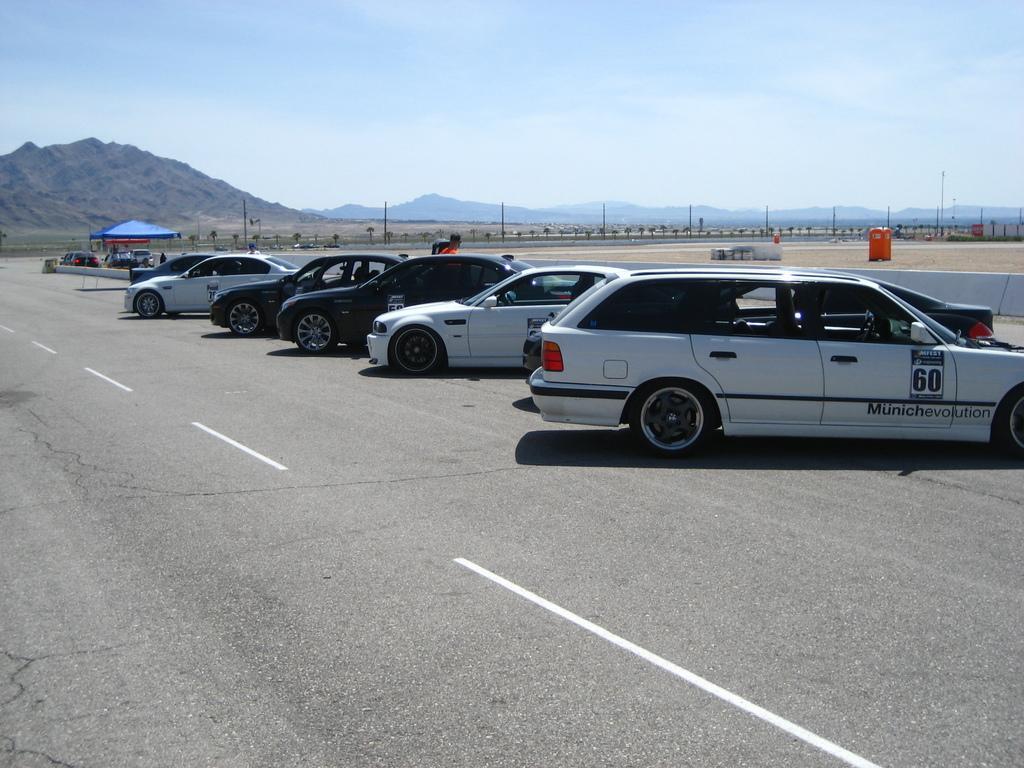Could you give a brief overview of what you see in this image? In the picture we can see a road and beside the road we can see some cars are parked and far away from it, we can see a tent and near it also we can see some cars are parked and in the background, we can see another road with some poles near it and behind it we can see hills and the sky with clouds. 